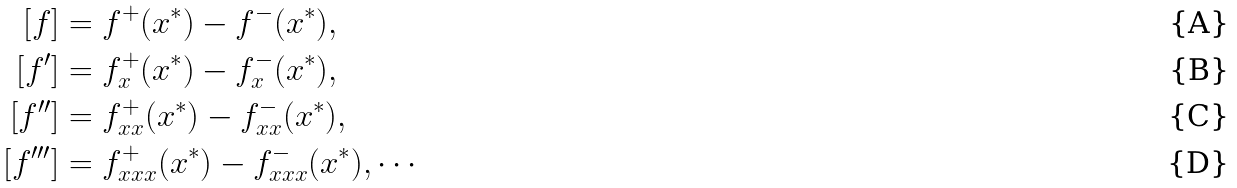<formula> <loc_0><loc_0><loc_500><loc_500>\left [ f \right ] & = f ^ { + } ( x ^ { * } ) - f ^ { - } ( x ^ { * } ) , \\ \left [ f ^ { \prime } \right ] & = f _ { x } ^ { + } ( x ^ { * } ) - f _ { x } ^ { - } ( x ^ { * } ) , \\ \left [ f ^ { \prime \prime } \right ] & = f _ { x x } ^ { + } ( x ^ { * } ) - f _ { x x } ^ { - } ( x ^ { * } ) , \\ \left [ f ^ { \prime \prime \prime } \right ] & = f _ { x x x } ^ { + } ( x ^ { * } ) - f _ { x x x } ^ { - } ( x ^ { * } ) , \cdots</formula> 